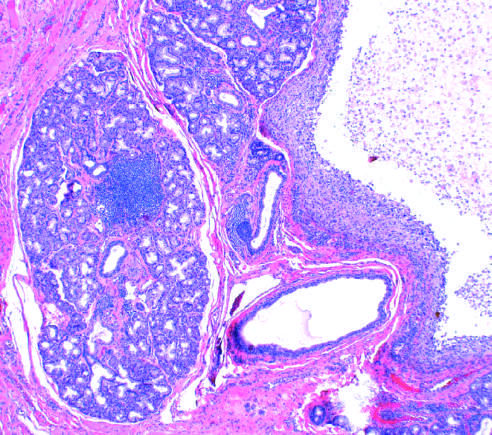where are the normal gland acini seen?
Answer the question using a single word or phrase. On the left 